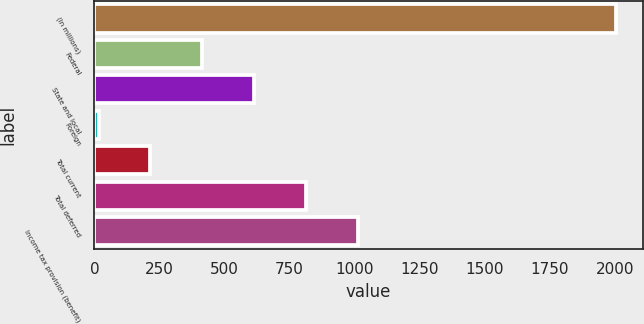<chart> <loc_0><loc_0><loc_500><loc_500><bar_chart><fcel>(In millions)<fcel>Federal<fcel>State and local<fcel>Foreign<fcel>Total current<fcel>Total deferred<fcel>Income tax provision (benefit)<nl><fcel>2006<fcel>414<fcel>613<fcel>16<fcel>215<fcel>812<fcel>1011<nl></chart> 